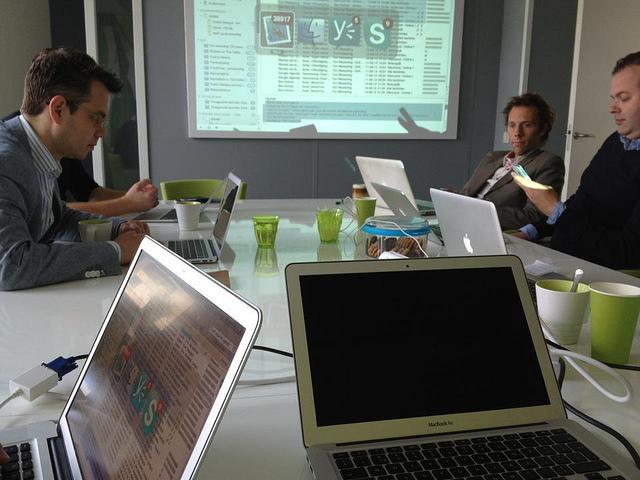What video chat icon is observed in the picture?
Write a very short answer. Skype. Do these men get paid for what they are doing right now?
Short answer required. Yes. Do the men at the table appear to be concentrating?
Concise answer only. Yes. 